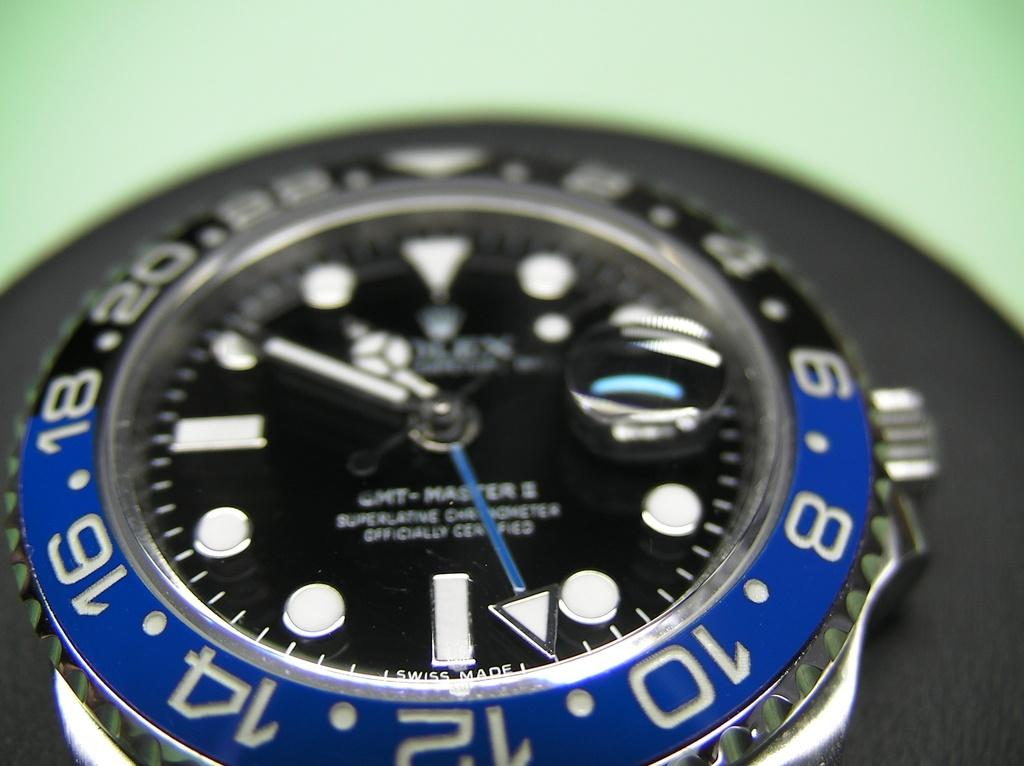<image>
Summarize the visual content of the image. The numbers on the blue part include 8, 10, 12 and 14. 